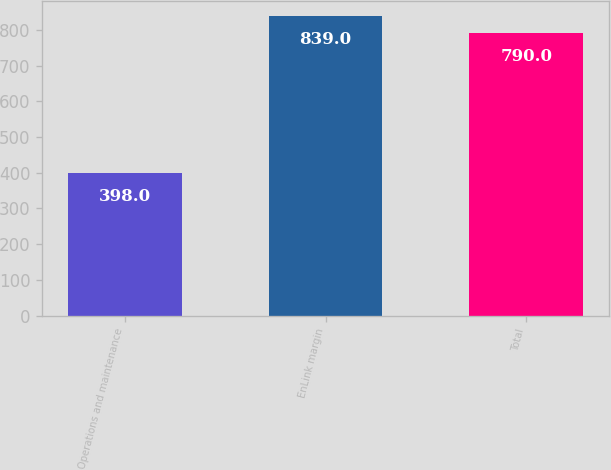Convert chart. <chart><loc_0><loc_0><loc_500><loc_500><bar_chart><fcel>Operations and maintenance<fcel>EnLink margin<fcel>Total<nl><fcel>398<fcel>839<fcel>790<nl></chart> 